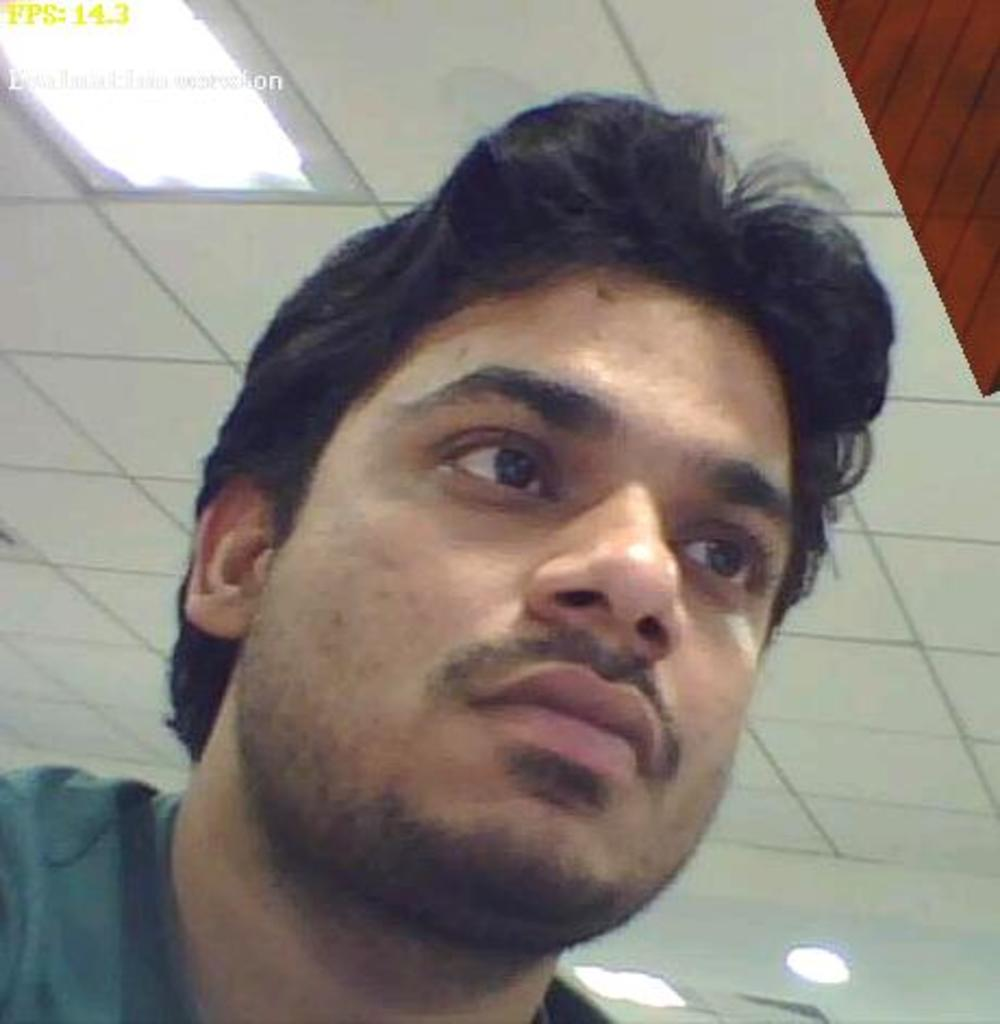What is the man in the image doing? The man is sitting in the image. What is the man wearing? The man is wearing a t-shirt. In which direction is the man looking? The man is looking to the right side. What can be seen on the ceiling in the image? There are lights attached to the ceiling in the image. What type of faucet can be seen in the image? There is no faucet present in the image. Is the man playing a game of chess in the image? There is no chess game or any indication of a chess game in the image. 